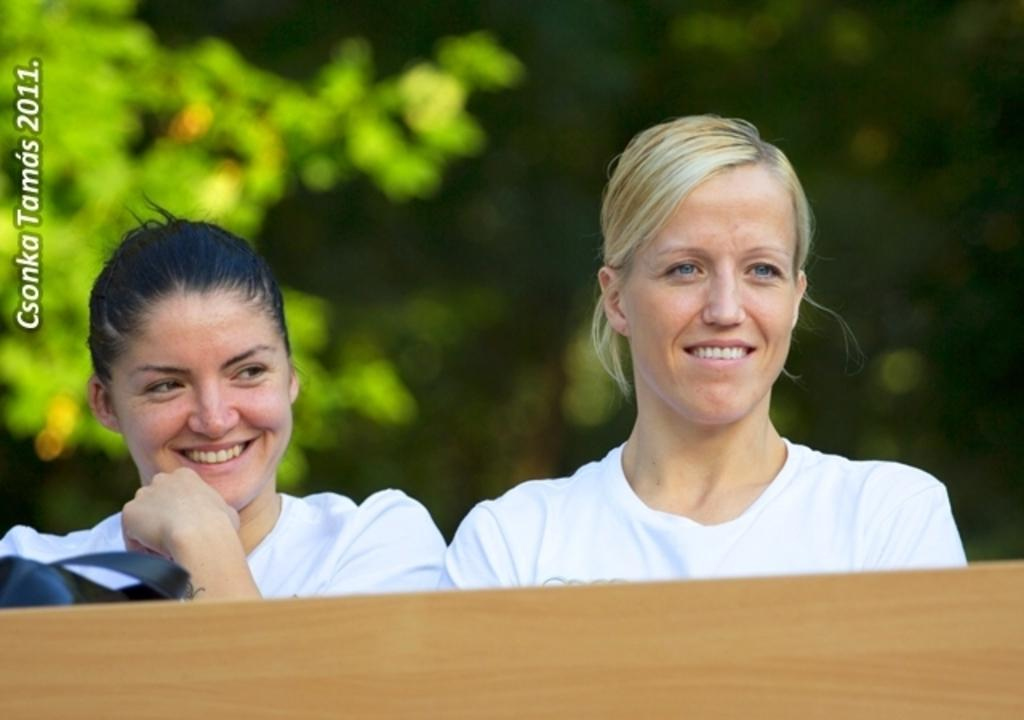How many people are in the image? There are two women in the image. What is located in the foreground area of the image? There is a table in the foreground area of the image. Can you describe the text on the left side of the image? Unfortunately, the specific content of the text cannot be determined from the image. What type of natural environment is visible in the background of the image? There is greenery in the background of the image. What type of lumber is being used to construct the form in the image? There is no form or lumber present in the image. 